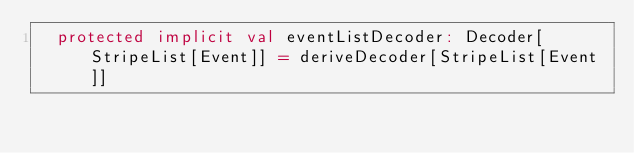<code> <loc_0><loc_0><loc_500><loc_500><_Scala_>  protected implicit val eventListDecoder: Decoder[StripeList[Event]] = deriveDecoder[StripeList[Event]]</code> 